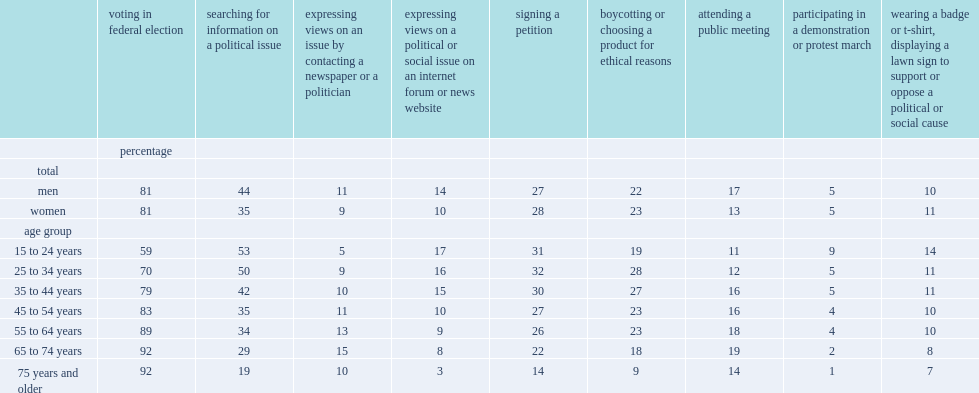The increase was especially pronounced among young adults aged 25 to 34: what was the percent of people had looked for information about a political issue in 2013? 50.0. The increase was especially pronounced among young adults aged 15 to 24: what was the percent of people had looked for information about a political issue in 2013? 53.0. 